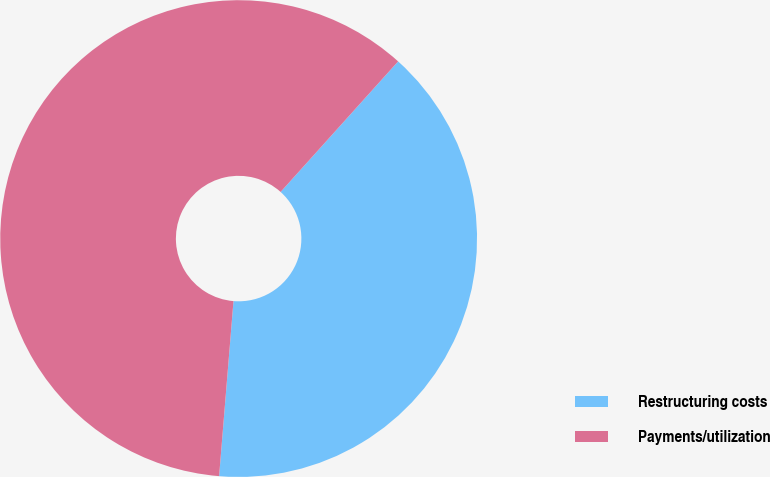Convert chart. <chart><loc_0><loc_0><loc_500><loc_500><pie_chart><fcel>Restructuring costs<fcel>Payments/utilization<nl><fcel>39.64%<fcel>60.36%<nl></chart> 